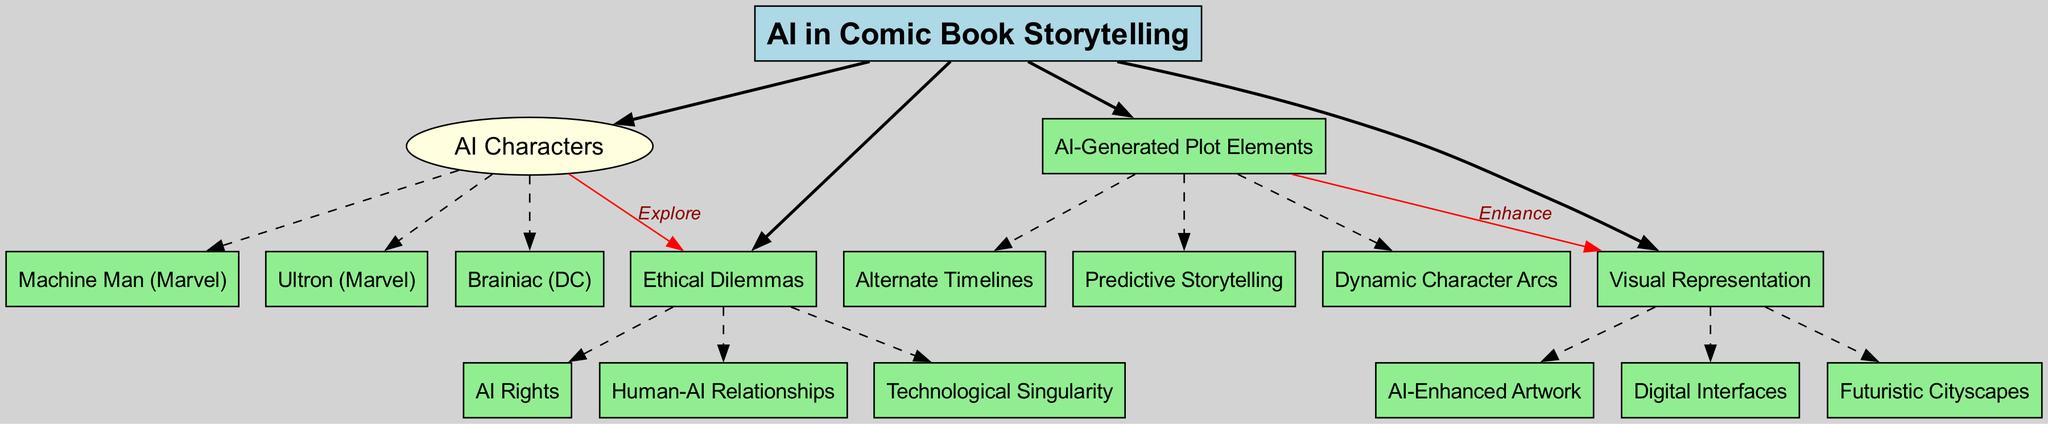What is the central concept of the diagram? The central concept node explicitly states "AI in Comic Book Storytelling," which represents the main theme of the diagram.
Answer: AI in Comic Book Storytelling How many main branches are represented in the diagram? The diagram shows four distinct main branches that stem from the central concept, each representing a different aspect of AI in comic book storytelling.
Answer: 4 Which AI character is specifically associated with the DC universe? The sub-branch under "AI Characters" lists "Brainiac," which is a well-known AI villain from the DC universe.
Answer: Brainiac What does "AI-Generated Plot Elements" enhance according to the diagram? The diagram indicates a connection from "AI-Generated Plot Elements" to "Visual Representation," signifying that these elements serve to enhance visual storytelling in comic books.
Answer: Visual Representation Which ethical dilemma is related to AI characters in the diagram? The diagram shows a link between "AI Characters" and "Ethical Dilemmas," indicating that one of the ethical issues explored is connected to AI characters, making the specific ethical dilemma "AI Rights."
Answer: AI Rights Name a sub-branch under "Visual Representation." Within "Visual Representation," one of the sub-branches is "AI-Enhanced Artwork," showcasing how artificial intelligence might influence the visual aspects of comic book storytelling.
Answer: AI-Enhanced Artwork What type of relationship does "AI Characters" explore according to the connections shown in the diagram? The connection labeled "Explore" from "AI Characters" to "Ethical Dilemmas" suggests that the relationship in question involves examining complex themes, specifically "Human-AI Relationships."
Answer: Human-AI Relationships How many sub-branches are listed under "AI-Generated Plot Elements"? Under "AI-Generated Plot Elements," there are three sub-branches provided, each representing different narrative techniques utilized in storytelling.
Answer: 3 What does "Predictive Storytelling" refer to in the context of the diagram? "Predictive Storytelling" is listed as one of the sub-branches of "AI-Generated Plot Elements," indicating a narrative technique where AI predicts possible plot developments and outcomes.
Answer: Predictive Storytelling 